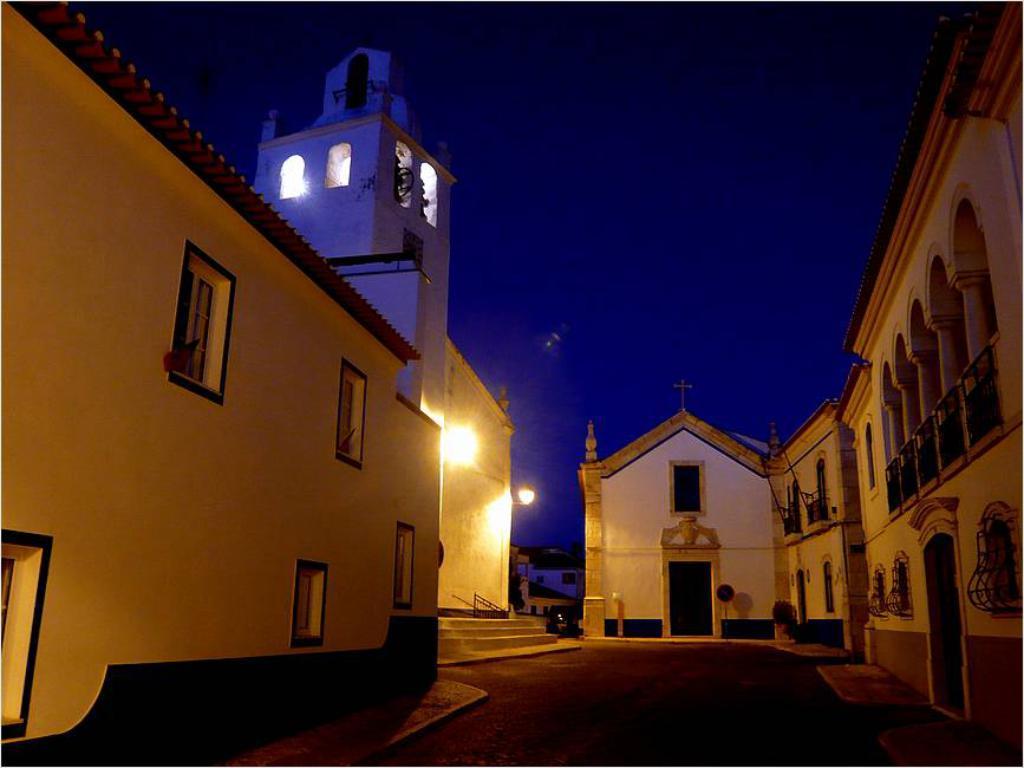How would you summarize this image in a sentence or two? In this image there are buildings and we can see lights. In the background there is sky. 